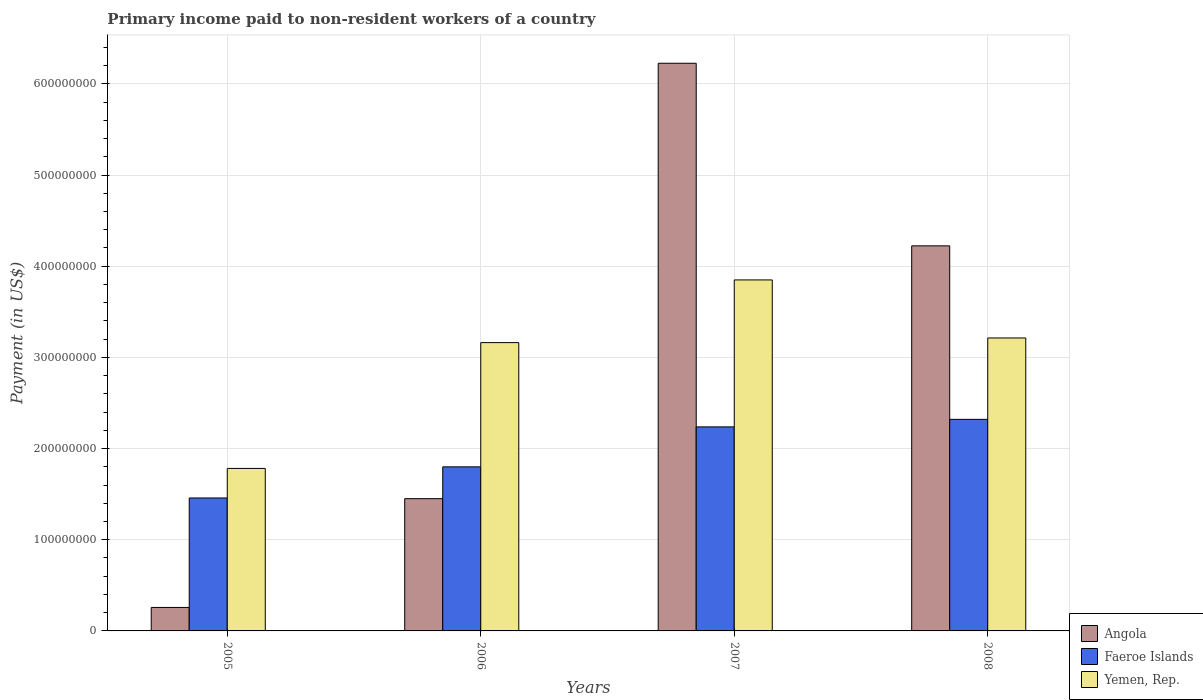Are the number of bars per tick equal to the number of legend labels?
Give a very brief answer. Yes. What is the label of the 1st group of bars from the left?
Keep it short and to the point. 2005. In how many cases, is the number of bars for a given year not equal to the number of legend labels?
Offer a terse response. 0. What is the amount paid to workers in Angola in 2008?
Offer a very short reply. 4.22e+08. Across all years, what is the maximum amount paid to workers in Faeroe Islands?
Offer a terse response. 2.32e+08. Across all years, what is the minimum amount paid to workers in Faeroe Islands?
Provide a short and direct response. 1.46e+08. What is the total amount paid to workers in Faeroe Islands in the graph?
Provide a short and direct response. 7.82e+08. What is the difference between the amount paid to workers in Angola in 2006 and that in 2008?
Offer a very short reply. -2.77e+08. What is the difference between the amount paid to workers in Angola in 2008 and the amount paid to workers in Yemen, Rep. in 2005?
Offer a very short reply. 2.44e+08. What is the average amount paid to workers in Yemen, Rep. per year?
Provide a short and direct response. 3.00e+08. In the year 2005, what is the difference between the amount paid to workers in Faeroe Islands and amount paid to workers in Angola?
Offer a very short reply. 1.20e+08. In how many years, is the amount paid to workers in Faeroe Islands greater than 340000000 US$?
Make the answer very short. 0. What is the ratio of the amount paid to workers in Faeroe Islands in 2005 to that in 2007?
Your answer should be compact. 0.65. Is the difference between the amount paid to workers in Faeroe Islands in 2006 and 2007 greater than the difference between the amount paid to workers in Angola in 2006 and 2007?
Offer a terse response. Yes. What is the difference between the highest and the second highest amount paid to workers in Faeroe Islands?
Offer a very short reply. 8.27e+06. What is the difference between the highest and the lowest amount paid to workers in Angola?
Provide a short and direct response. 5.97e+08. In how many years, is the amount paid to workers in Yemen, Rep. greater than the average amount paid to workers in Yemen, Rep. taken over all years?
Give a very brief answer. 3. What does the 1st bar from the left in 2005 represents?
Your answer should be compact. Angola. What does the 3rd bar from the right in 2008 represents?
Make the answer very short. Angola. Is it the case that in every year, the sum of the amount paid to workers in Faeroe Islands and amount paid to workers in Angola is greater than the amount paid to workers in Yemen, Rep.?
Give a very brief answer. No. Are all the bars in the graph horizontal?
Provide a succinct answer. No. How many years are there in the graph?
Provide a short and direct response. 4. Are the values on the major ticks of Y-axis written in scientific E-notation?
Your answer should be compact. No. Does the graph contain any zero values?
Provide a succinct answer. No. Does the graph contain grids?
Keep it short and to the point. Yes. Where does the legend appear in the graph?
Ensure brevity in your answer.  Bottom right. How are the legend labels stacked?
Offer a terse response. Vertical. What is the title of the graph?
Ensure brevity in your answer.  Primary income paid to non-resident workers of a country. Does "Guatemala" appear as one of the legend labels in the graph?
Your answer should be very brief. No. What is the label or title of the X-axis?
Keep it short and to the point. Years. What is the label or title of the Y-axis?
Provide a short and direct response. Payment (in US$). What is the Payment (in US$) in Angola in 2005?
Give a very brief answer. 2.58e+07. What is the Payment (in US$) of Faeroe Islands in 2005?
Your response must be concise. 1.46e+08. What is the Payment (in US$) in Yemen, Rep. in 2005?
Your answer should be very brief. 1.78e+08. What is the Payment (in US$) in Angola in 2006?
Provide a short and direct response. 1.45e+08. What is the Payment (in US$) in Faeroe Islands in 2006?
Your answer should be very brief. 1.80e+08. What is the Payment (in US$) in Yemen, Rep. in 2006?
Your answer should be very brief. 3.16e+08. What is the Payment (in US$) in Angola in 2007?
Offer a terse response. 6.23e+08. What is the Payment (in US$) of Faeroe Islands in 2007?
Your answer should be very brief. 2.24e+08. What is the Payment (in US$) in Yemen, Rep. in 2007?
Your answer should be very brief. 3.85e+08. What is the Payment (in US$) of Angola in 2008?
Ensure brevity in your answer.  4.22e+08. What is the Payment (in US$) of Faeroe Islands in 2008?
Make the answer very short. 2.32e+08. What is the Payment (in US$) of Yemen, Rep. in 2008?
Offer a terse response. 3.21e+08. Across all years, what is the maximum Payment (in US$) in Angola?
Your answer should be compact. 6.23e+08. Across all years, what is the maximum Payment (in US$) in Faeroe Islands?
Your response must be concise. 2.32e+08. Across all years, what is the maximum Payment (in US$) of Yemen, Rep.?
Your answer should be compact. 3.85e+08. Across all years, what is the minimum Payment (in US$) in Angola?
Your response must be concise. 2.58e+07. Across all years, what is the minimum Payment (in US$) in Faeroe Islands?
Provide a short and direct response. 1.46e+08. Across all years, what is the minimum Payment (in US$) of Yemen, Rep.?
Offer a terse response. 1.78e+08. What is the total Payment (in US$) of Angola in the graph?
Offer a terse response. 1.22e+09. What is the total Payment (in US$) in Faeroe Islands in the graph?
Offer a terse response. 7.82e+08. What is the total Payment (in US$) in Yemen, Rep. in the graph?
Keep it short and to the point. 1.20e+09. What is the difference between the Payment (in US$) of Angola in 2005 and that in 2006?
Ensure brevity in your answer.  -1.19e+08. What is the difference between the Payment (in US$) in Faeroe Islands in 2005 and that in 2006?
Your answer should be compact. -3.41e+07. What is the difference between the Payment (in US$) in Yemen, Rep. in 2005 and that in 2006?
Provide a short and direct response. -1.38e+08. What is the difference between the Payment (in US$) of Angola in 2005 and that in 2007?
Provide a succinct answer. -5.97e+08. What is the difference between the Payment (in US$) in Faeroe Islands in 2005 and that in 2007?
Offer a terse response. -7.80e+07. What is the difference between the Payment (in US$) in Yemen, Rep. in 2005 and that in 2007?
Keep it short and to the point. -2.07e+08. What is the difference between the Payment (in US$) in Angola in 2005 and that in 2008?
Offer a very short reply. -3.97e+08. What is the difference between the Payment (in US$) of Faeroe Islands in 2005 and that in 2008?
Your answer should be very brief. -8.62e+07. What is the difference between the Payment (in US$) in Yemen, Rep. in 2005 and that in 2008?
Provide a succinct answer. -1.43e+08. What is the difference between the Payment (in US$) of Angola in 2006 and that in 2007?
Your answer should be compact. -4.78e+08. What is the difference between the Payment (in US$) of Faeroe Islands in 2006 and that in 2007?
Make the answer very short. -4.38e+07. What is the difference between the Payment (in US$) in Yemen, Rep. in 2006 and that in 2007?
Offer a very short reply. -6.87e+07. What is the difference between the Payment (in US$) of Angola in 2006 and that in 2008?
Make the answer very short. -2.77e+08. What is the difference between the Payment (in US$) of Faeroe Islands in 2006 and that in 2008?
Your answer should be compact. -5.21e+07. What is the difference between the Payment (in US$) of Yemen, Rep. in 2006 and that in 2008?
Offer a terse response. -5.10e+06. What is the difference between the Payment (in US$) in Angola in 2007 and that in 2008?
Give a very brief answer. 2.00e+08. What is the difference between the Payment (in US$) in Faeroe Islands in 2007 and that in 2008?
Give a very brief answer. -8.27e+06. What is the difference between the Payment (in US$) in Yemen, Rep. in 2007 and that in 2008?
Your response must be concise. 6.36e+07. What is the difference between the Payment (in US$) of Angola in 2005 and the Payment (in US$) of Faeroe Islands in 2006?
Keep it short and to the point. -1.54e+08. What is the difference between the Payment (in US$) of Angola in 2005 and the Payment (in US$) of Yemen, Rep. in 2006?
Offer a very short reply. -2.90e+08. What is the difference between the Payment (in US$) of Faeroe Islands in 2005 and the Payment (in US$) of Yemen, Rep. in 2006?
Offer a very short reply. -1.70e+08. What is the difference between the Payment (in US$) in Angola in 2005 and the Payment (in US$) in Faeroe Islands in 2007?
Provide a succinct answer. -1.98e+08. What is the difference between the Payment (in US$) of Angola in 2005 and the Payment (in US$) of Yemen, Rep. in 2007?
Provide a succinct answer. -3.59e+08. What is the difference between the Payment (in US$) of Faeroe Islands in 2005 and the Payment (in US$) of Yemen, Rep. in 2007?
Your answer should be very brief. -2.39e+08. What is the difference between the Payment (in US$) of Angola in 2005 and the Payment (in US$) of Faeroe Islands in 2008?
Offer a very short reply. -2.06e+08. What is the difference between the Payment (in US$) of Angola in 2005 and the Payment (in US$) of Yemen, Rep. in 2008?
Make the answer very short. -2.96e+08. What is the difference between the Payment (in US$) of Faeroe Islands in 2005 and the Payment (in US$) of Yemen, Rep. in 2008?
Give a very brief answer. -1.75e+08. What is the difference between the Payment (in US$) in Angola in 2006 and the Payment (in US$) in Faeroe Islands in 2007?
Provide a short and direct response. -7.87e+07. What is the difference between the Payment (in US$) in Angola in 2006 and the Payment (in US$) in Yemen, Rep. in 2007?
Your response must be concise. -2.40e+08. What is the difference between the Payment (in US$) in Faeroe Islands in 2006 and the Payment (in US$) in Yemen, Rep. in 2007?
Offer a very short reply. -2.05e+08. What is the difference between the Payment (in US$) in Angola in 2006 and the Payment (in US$) in Faeroe Islands in 2008?
Offer a terse response. -8.70e+07. What is the difference between the Payment (in US$) in Angola in 2006 and the Payment (in US$) in Yemen, Rep. in 2008?
Make the answer very short. -1.76e+08. What is the difference between the Payment (in US$) in Faeroe Islands in 2006 and the Payment (in US$) in Yemen, Rep. in 2008?
Offer a very short reply. -1.41e+08. What is the difference between the Payment (in US$) of Angola in 2007 and the Payment (in US$) of Faeroe Islands in 2008?
Provide a succinct answer. 3.91e+08. What is the difference between the Payment (in US$) of Angola in 2007 and the Payment (in US$) of Yemen, Rep. in 2008?
Ensure brevity in your answer.  3.01e+08. What is the difference between the Payment (in US$) of Faeroe Islands in 2007 and the Payment (in US$) of Yemen, Rep. in 2008?
Offer a very short reply. -9.75e+07. What is the average Payment (in US$) in Angola per year?
Offer a very short reply. 3.04e+08. What is the average Payment (in US$) of Faeroe Islands per year?
Your response must be concise. 1.95e+08. What is the average Payment (in US$) in Yemen, Rep. per year?
Give a very brief answer. 3.00e+08. In the year 2005, what is the difference between the Payment (in US$) in Angola and Payment (in US$) in Faeroe Islands?
Offer a terse response. -1.20e+08. In the year 2005, what is the difference between the Payment (in US$) of Angola and Payment (in US$) of Yemen, Rep.?
Offer a terse response. -1.52e+08. In the year 2005, what is the difference between the Payment (in US$) in Faeroe Islands and Payment (in US$) in Yemen, Rep.?
Provide a short and direct response. -3.24e+07. In the year 2006, what is the difference between the Payment (in US$) in Angola and Payment (in US$) in Faeroe Islands?
Give a very brief answer. -3.49e+07. In the year 2006, what is the difference between the Payment (in US$) of Angola and Payment (in US$) of Yemen, Rep.?
Your response must be concise. -1.71e+08. In the year 2006, what is the difference between the Payment (in US$) of Faeroe Islands and Payment (in US$) of Yemen, Rep.?
Your answer should be very brief. -1.36e+08. In the year 2007, what is the difference between the Payment (in US$) in Angola and Payment (in US$) in Faeroe Islands?
Your answer should be very brief. 3.99e+08. In the year 2007, what is the difference between the Payment (in US$) in Angola and Payment (in US$) in Yemen, Rep.?
Your answer should be very brief. 2.38e+08. In the year 2007, what is the difference between the Payment (in US$) in Faeroe Islands and Payment (in US$) in Yemen, Rep.?
Offer a very short reply. -1.61e+08. In the year 2008, what is the difference between the Payment (in US$) of Angola and Payment (in US$) of Faeroe Islands?
Make the answer very short. 1.90e+08. In the year 2008, what is the difference between the Payment (in US$) of Angola and Payment (in US$) of Yemen, Rep.?
Offer a very short reply. 1.01e+08. In the year 2008, what is the difference between the Payment (in US$) in Faeroe Islands and Payment (in US$) in Yemen, Rep.?
Provide a short and direct response. -8.93e+07. What is the ratio of the Payment (in US$) of Angola in 2005 to that in 2006?
Provide a succinct answer. 0.18. What is the ratio of the Payment (in US$) of Faeroe Islands in 2005 to that in 2006?
Make the answer very short. 0.81. What is the ratio of the Payment (in US$) in Yemen, Rep. in 2005 to that in 2006?
Provide a short and direct response. 0.56. What is the ratio of the Payment (in US$) in Angola in 2005 to that in 2007?
Provide a succinct answer. 0.04. What is the ratio of the Payment (in US$) of Faeroe Islands in 2005 to that in 2007?
Offer a very short reply. 0.65. What is the ratio of the Payment (in US$) of Yemen, Rep. in 2005 to that in 2007?
Keep it short and to the point. 0.46. What is the ratio of the Payment (in US$) in Angola in 2005 to that in 2008?
Make the answer very short. 0.06. What is the ratio of the Payment (in US$) of Faeroe Islands in 2005 to that in 2008?
Your answer should be very brief. 0.63. What is the ratio of the Payment (in US$) in Yemen, Rep. in 2005 to that in 2008?
Your answer should be very brief. 0.55. What is the ratio of the Payment (in US$) in Angola in 2006 to that in 2007?
Offer a terse response. 0.23. What is the ratio of the Payment (in US$) in Faeroe Islands in 2006 to that in 2007?
Your response must be concise. 0.8. What is the ratio of the Payment (in US$) in Yemen, Rep. in 2006 to that in 2007?
Provide a short and direct response. 0.82. What is the ratio of the Payment (in US$) in Angola in 2006 to that in 2008?
Ensure brevity in your answer.  0.34. What is the ratio of the Payment (in US$) of Faeroe Islands in 2006 to that in 2008?
Provide a short and direct response. 0.78. What is the ratio of the Payment (in US$) in Yemen, Rep. in 2006 to that in 2008?
Your answer should be very brief. 0.98. What is the ratio of the Payment (in US$) in Angola in 2007 to that in 2008?
Offer a very short reply. 1.47. What is the ratio of the Payment (in US$) of Faeroe Islands in 2007 to that in 2008?
Your response must be concise. 0.96. What is the ratio of the Payment (in US$) in Yemen, Rep. in 2007 to that in 2008?
Your answer should be very brief. 1.2. What is the difference between the highest and the second highest Payment (in US$) of Angola?
Your answer should be very brief. 2.00e+08. What is the difference between the highest and the second highest Payment (in US$) of Faeroe Islands?
Provide a succinct answer. 8.27e+06. What is the difference between the highest and the second highest Payment (in US$) in Yemen, Rep.?
Provide a short and direct response. 6.36e+07. What is the difference between the highest and the lowest Payment (in US$) in Angola?
Offer a terse response. 5.97e+08. What is the difference between the highest and the lowest Payment (in US$) in Faeroe Islands?
Offer a very short reply. 8.62e+07. What is the difference between the highest and the lowest Payment (in US$) of Yemen, Rep.?
Provide a short and direct response. 2.07e+08. 